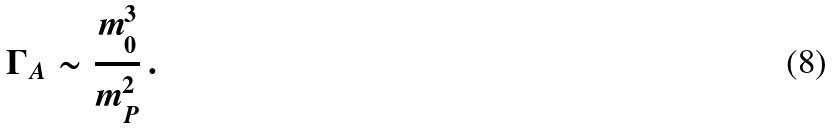<formula> <loc_0><loc_0><loc_500><loc_500>\Gamma _ { A } \sim \frac { m _ { 0 } ^ { 3 } } { m _ { P } ^ { 2 } } \, .</formula> 